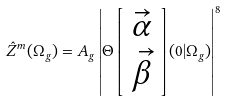Convert formula to latex. <formula><loc_0><loc_0><loc_500><loc_500>\hat { Z } ^ { m } ( \Omega _ { g } ) = A _ { g } \left | \Theta \left [ \begin{array} { c } { { { \vec { \alpha } } } } \\ { { { \vec { \beta } } } } \end{array} \right ] ( 0 | \Omega _ { g } ) \right | ^ { 8 }</formula> 